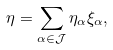Convert formula to latex. <formula><loc_0><loc_0><loc_500><loc_500>\eta = \sum _ { \alpha \in \mathcal { J } } \eta _ { \alpha } \xi _ { \alpha } ,</formula> 